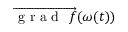<formula> <loc_0><loc_0><loc_500><loc_500>\overrightarrow { g r a d f } ( \omega ( t ) )</formula> 